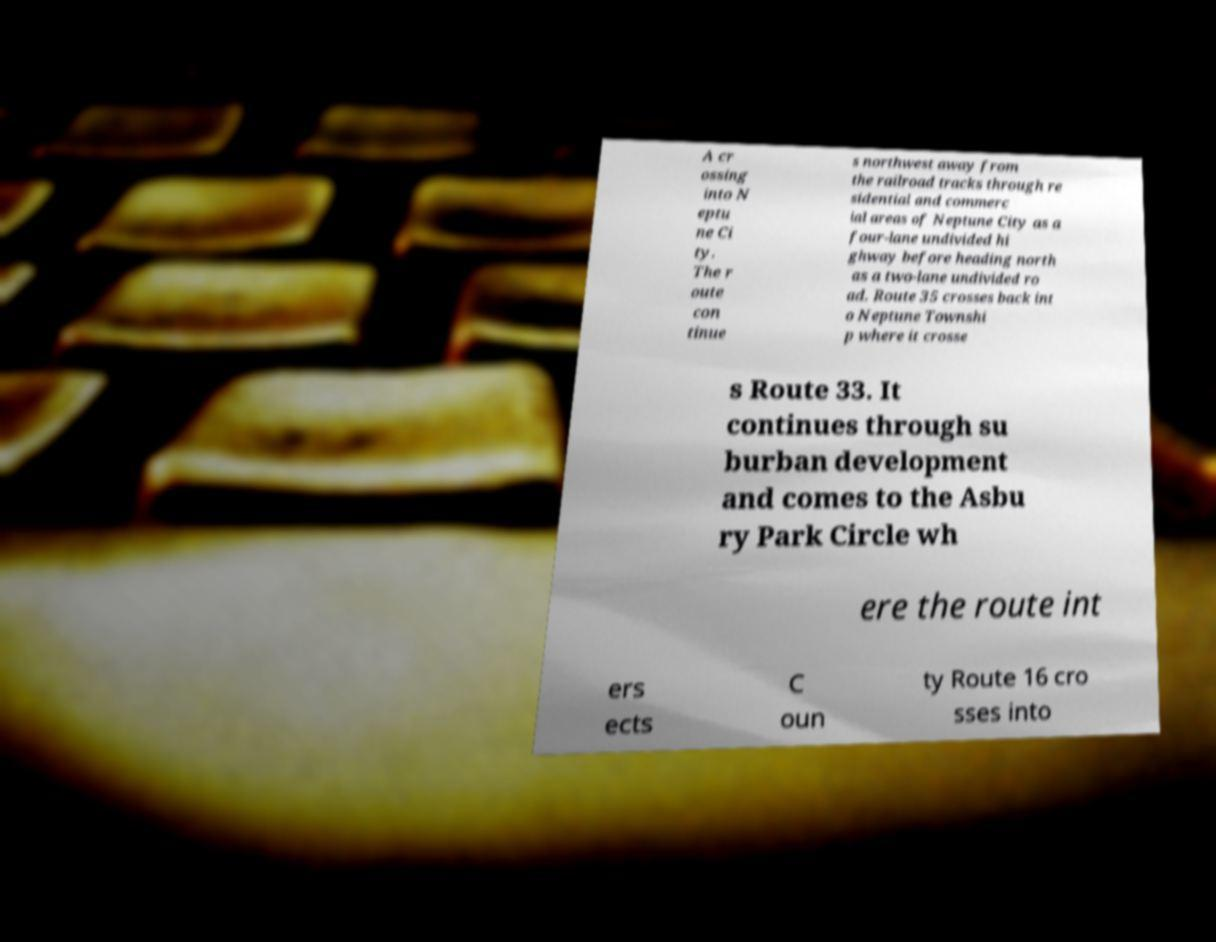There's text embedded in this image that I need extracted. Can you transcribe it verbatim? A cr ossing into N eptu ne Ci ty. The r oute con tinue s northwest away from the railroad tracks through re sidential and commerc ial areas of Neptune City as a four-lane undivided hi ghway before heading north as a two-lane undivided ro ad. Route 35 crosses back int o Neptune Townshi p where it crosse s Route 33. It continues through su burban development and comes to the Asbu ry Park Circle wh ere the route int ers ects C oun ty Route 16 cro sses into 